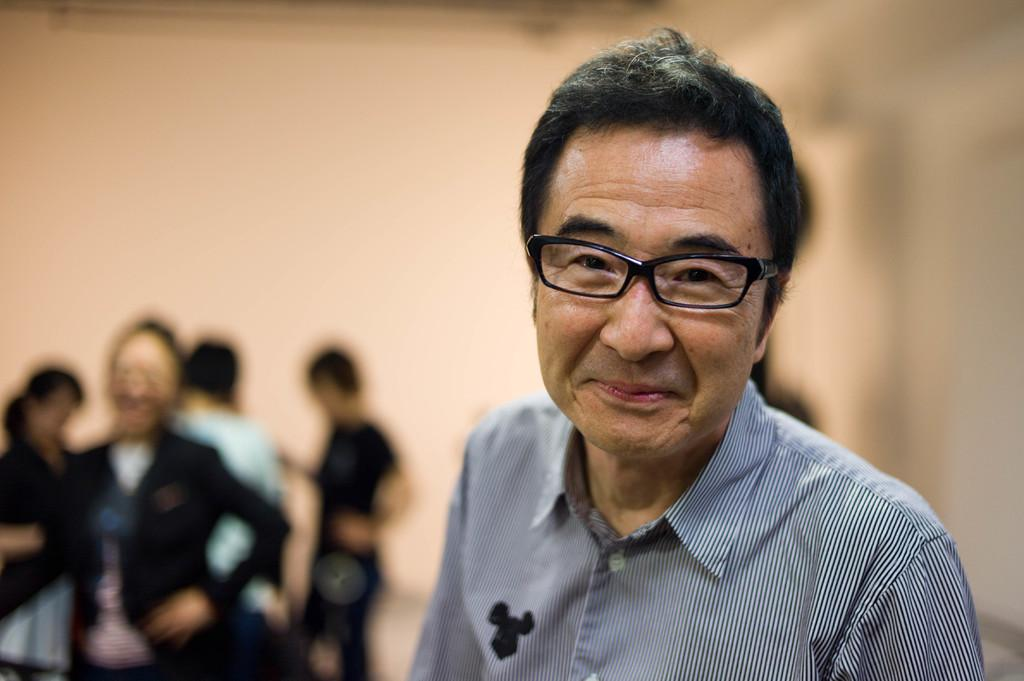Who is the main subject in the image? There is a man in the image. What is the man doing in the image? The man is standing. What is the man wearing in the image? The man is wearing a striped shirt and black spectacles. Can you describe the people in the background of the image? There are other people in the background of the image, but they are not clearly visible due to the blurred background. What type of spoon is the man holding in the image? There is no spoon present in the image. Can you tell me the name of the man's partner in the image? There is no partner visible in the image, as the focus is on the man standing alone. 